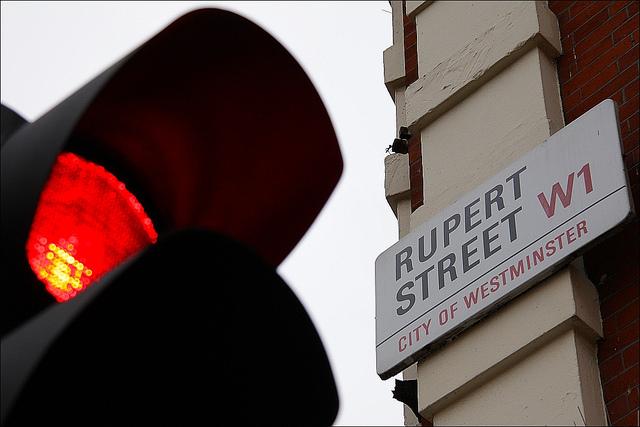Can the cars go through this light?
Give a very brief answer. No. What color are the writing?
Keep it brief. Black and red. What city is Rupert Street in?
Keep it brief. Westminster. 